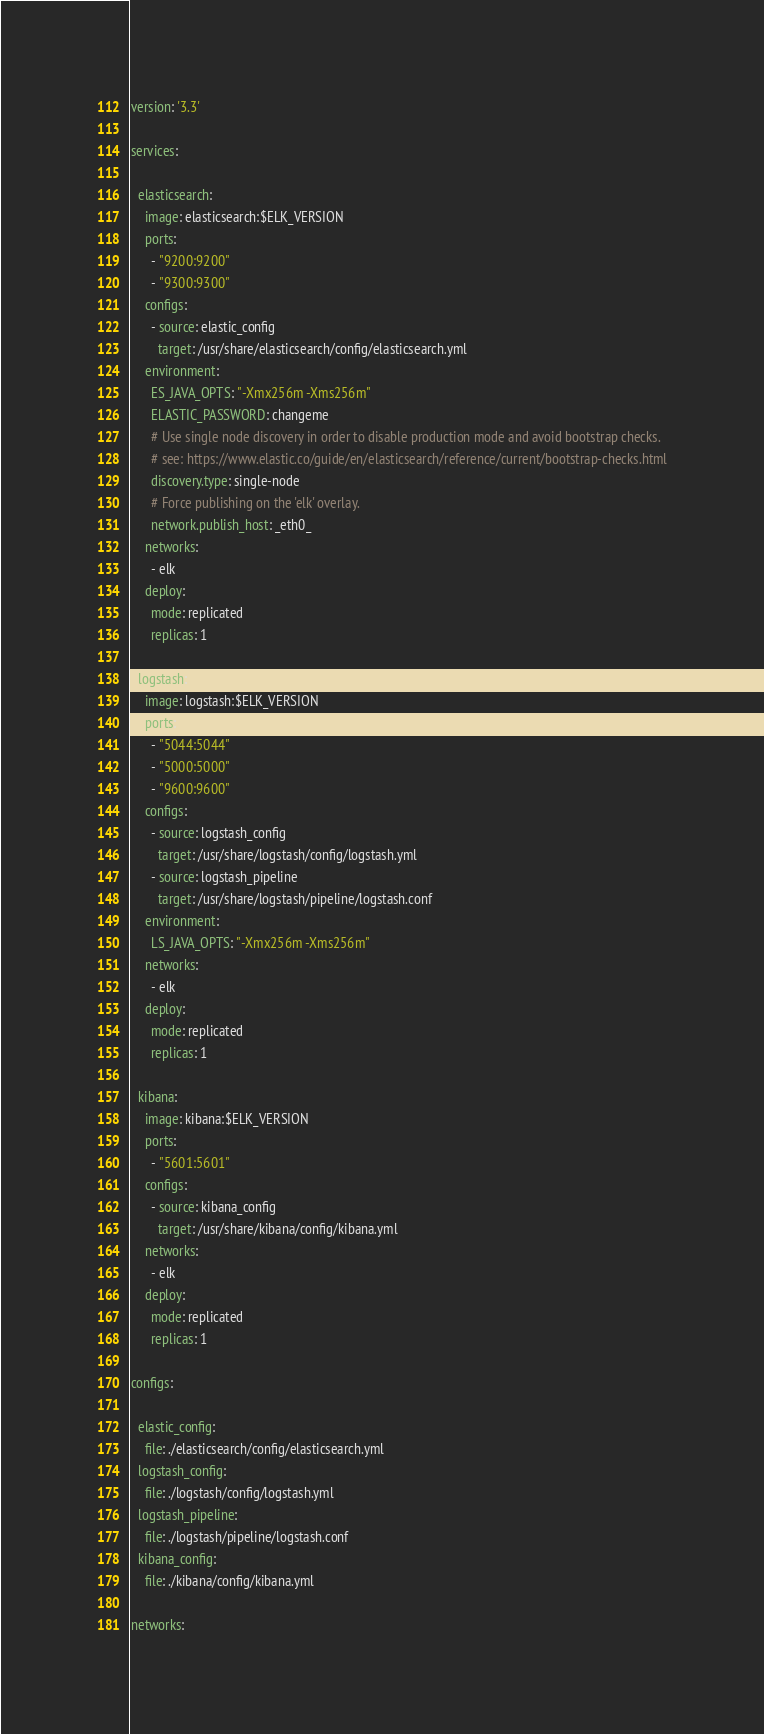Convert code to text. <code><loc_0><loc_0><loc_500><loc_500><_YAML_>version: '3.3'

services:

  elasticsearch:
    image: elasticsearch:$ELK_VERSION
    ports:
      - "9200:9200"
      - "9300:9300"
    configs:
      - source: elastic_config
        target: /usr/share/elasticsearch/config/elasticsearch.yml
    environment:
      ES_JAVA_OPTS: "-Xmx256m -Xms256m"
      ELASTIC_PASSWORD: changeme
      # Use single node discovery in order to disable production mode and avoid bootstrap checks.
      # see: https://www.elastic.co/guide/en/elasticsearch/reference/current/bootstrap-checks.html
      discovery.type: single-node
      # Force publishing on the 'elk' overlay.
      network.publish_host: _eth0_
    networks:
      - elk
    deploy:
      mode: replicated
      replicas: 1

  logstash:
    image: logstash:$ELK_VERSION
    ports:
      - "5044:5044"
      - "5000:5000"
      - "9600:9600"
    configs:
      - source: logstash_config
        target: /usr/share/logstash/config/logstash.yml
      - source: logstash_pipeline
        target: /usr/share/logstash/pipeline/logstash.conf
    environment:
      LS_JAVA_OPTS: "-Xmx256m -Xms256m"
    networks:
      - elk
    deploy:
      mode: replicated
      replicas: 1

  kibana:
    image: kibana:$ELK_VERSION
    ports:
      - "5601:5601"
    configs:
      - source: kibana_config
        target: /usr/share/kibana/config/kibana.yml
    networks:
      - elk
    deploy:
      mode: replicated
      replicas: 1

configs:

  elastic_config:
    file: ./elasticsearch/config/elasticsearch.yml
  logstash_config:
    file: ./logstash/config/logstash.yml
  logstash_pipeline:
    file: ./logstash/pipeline/logstash.conf
  kibana_config:
    file: ./kibana/config/kibana.yml

networks:</code> 